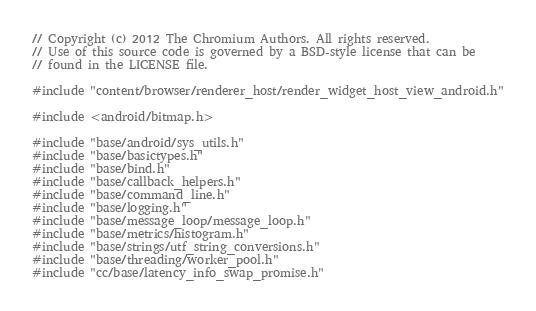Convert code to text. <code><loc_0><loc_0><loc_500><loc_500><_C++_>// Copyright (c) 2012 The Chromium Authors. All rights reserved.
// Use of this source code is governed by a BSD-style license that can be
// found in the LICENSE file.

#include "content/browser/renderer_host/render_widget_host_view_android.h"

#include <android/bitmap.h>

#include "base/android/sys_utils.h"
#include "base/basictypes.h"
#include "base/bind.h"
#include "base/callback_helpers.h"
#include "base/command_line.h"
#include "base/logging.h"
#include "base/message_loop/message_loop.h"
#include "base/metrics/histogram.h"
#include "base/strings/utf_string_conversions.h"
#include "base/threading/worker_pool.h"
#include "cc/base/latency_info_swap_promise.h"</code> 